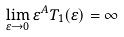<formula> <loc_0><loc_0><loc_500><loc_500>\lim _ { \varepsilon \rightarrow 0 } \varepsilon ^ { A } T _ { 1 } ( \varepsilon ) = \infty</formula> 